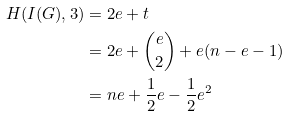<formula> <loc_0><loc_0><loc_500><loc_500>H ( I ( G ) , 3 ) & = 2 e + t \\ & = 2 e + \binom { e } { 2 } + e ( n - e - 1 ) \\ & = n e + \frac { 1 } { 2 } e - \frac { 1 } { 2 } e ^ { 2 }</formula> 